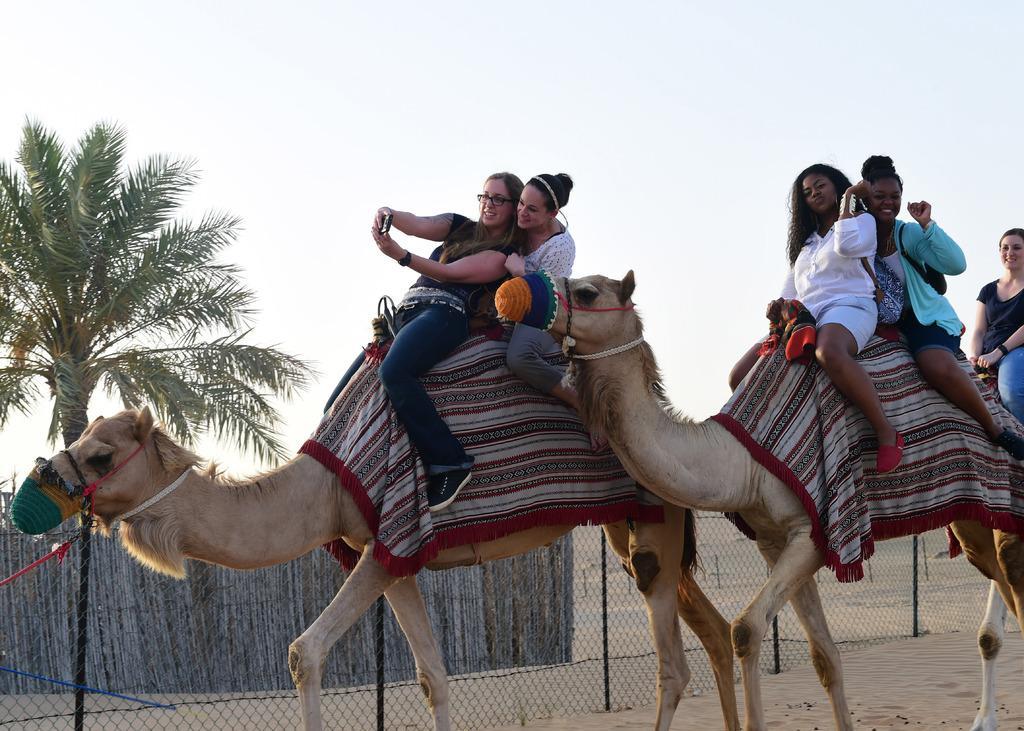Please provide a concise description of this image. In this image we can see women sitting on the camel's, mesh, wooden fence, tree and sky. 